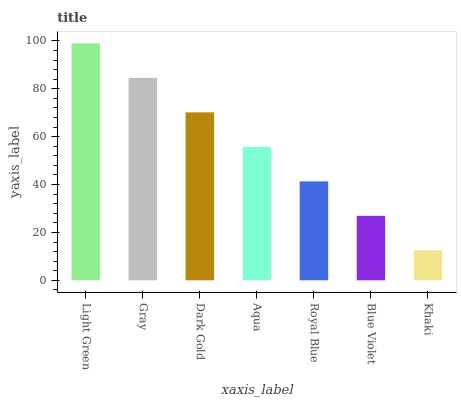Is Khaki the minimum?
Answer yes or no. Yes. Is Light Green the maximum?
Answer yes or no. Yes. Is Gray the minimum?
Answer yes or no. No. Is Gray the maximum?
Answer yes or no. No. Is Light Green greater than Gray?
Answer yes or no. Yes. Is Gray less than Light Green?
Answer yes or no. Yes. Is Gray greater than Light Green?
Answer yes or no. No. Is Light Green less than Gray?
Answer yes or no. No. Is Aqua the high median?
Answer yes or no. Yes. Is Aqua the low median?
Answer yes or no. Yes. Is Gray the high median?
Answer yes or no. No. Is Blue Violet the low median?
Answer yes or no. No. 